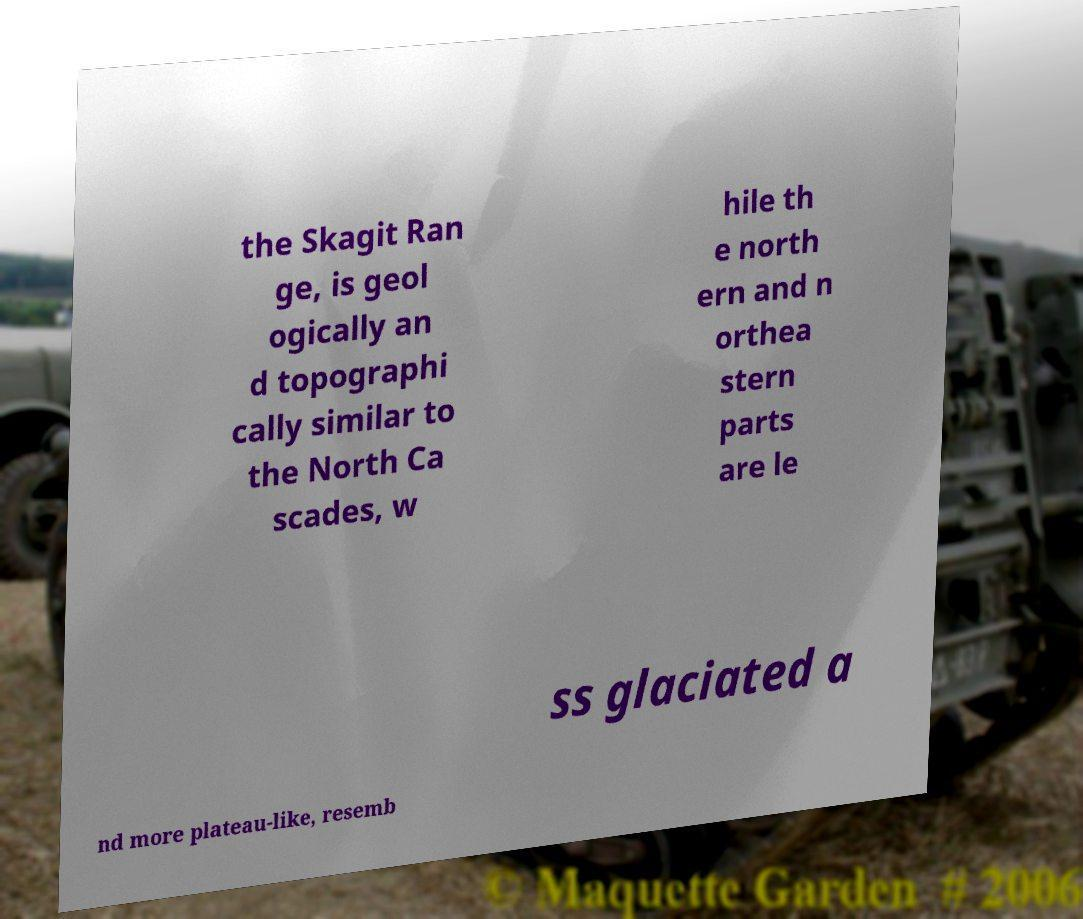Can you accurately transcribe the text from the provided image for me? the Skagit Ran ge, is geol ogically an d topographi cally similar to the North Ca scades, w hile th e north ern and n orthea stern parts are le ss glaciated a nd more plateau-like, resemb 